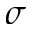<formula> <loc_0><loc_0><loc_500><loc_500>\sigma</formula> 